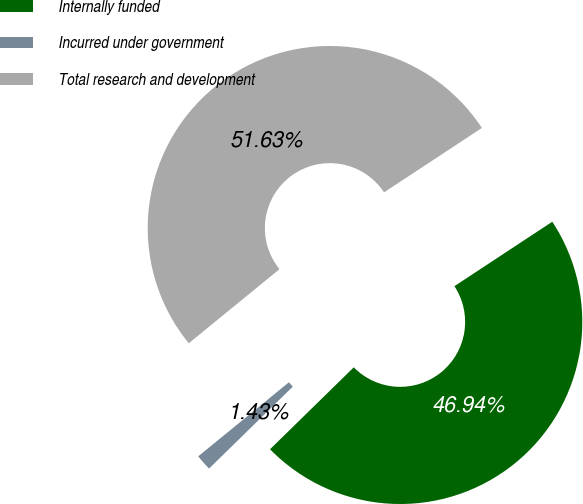<chart> <loc_0><loc_0><loc_500><loc_500><pie_chart><fcel>Internally funded<fcel>Incurred under government<fcel>Total research and development<nl><fcel>46.94%<fcel>1.43%<fcel>51.63%<nl></chart> 